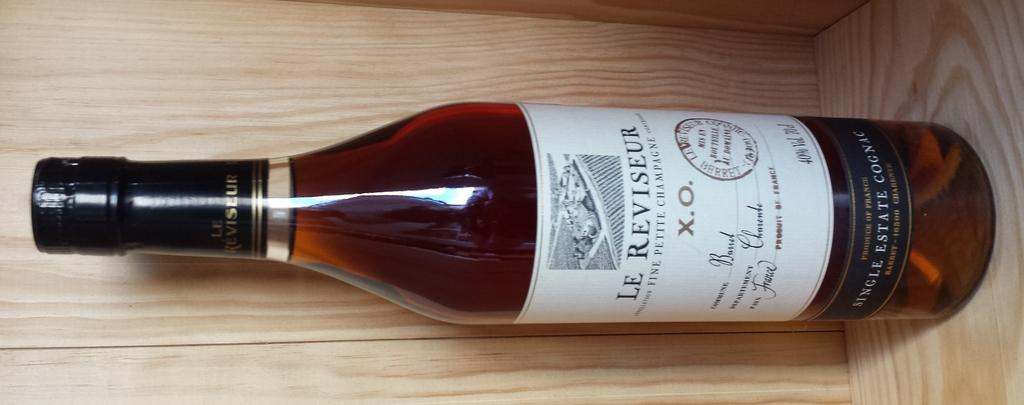What is the main object in the image? There is an alcohol bottle in the image. What type of surface is the alcohol bottle placed on? The alcohol bottle is on a wooden surface. What type of cracker is placed next to the alcohol bottle in the image? There is no cracker present in the image. What type of silk material is draped over the alcohol bottle in the image? There is no silk material present in the image. 